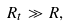Convert formula to latex. <formula><loc_0><loc_0><loc_500><loc_500>R _ { t } \gg R ,</formula> 